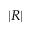Convert formula to latex. <formula><loc_0><loc_0><loc_500><loc_500>| R |</formula> 